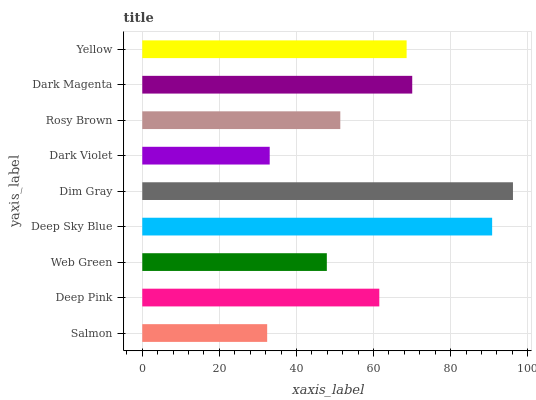Is Salmon the minimum?
Answer yes or no. Yes. Is Dim Gray the maximum?
Answer yes or no. Yes. Is Deep Pink the minimum?
Answer yes or no. No. Is Deep Pink the maximum?
Answer yes or no. No. Is Deep Pink greater than Salmon?
Answer yes or no. Yes. Is Salmon less than Deep Pink?
Answer yes or no. Yes. Is Salmon greater than Deep Pink?
Answer yes or no. No. Is Deep Pink less than Salmon?
Answer yes or no. No. Is Deep Pink the high median?
Answer yes or no. Yes. Is Deep Pink the low median?
Answer yes or no. Yes. Is Dark Violet the high median?
Answer yes or no. No. Is Salmon the low median?
Answer yes or no. No. 